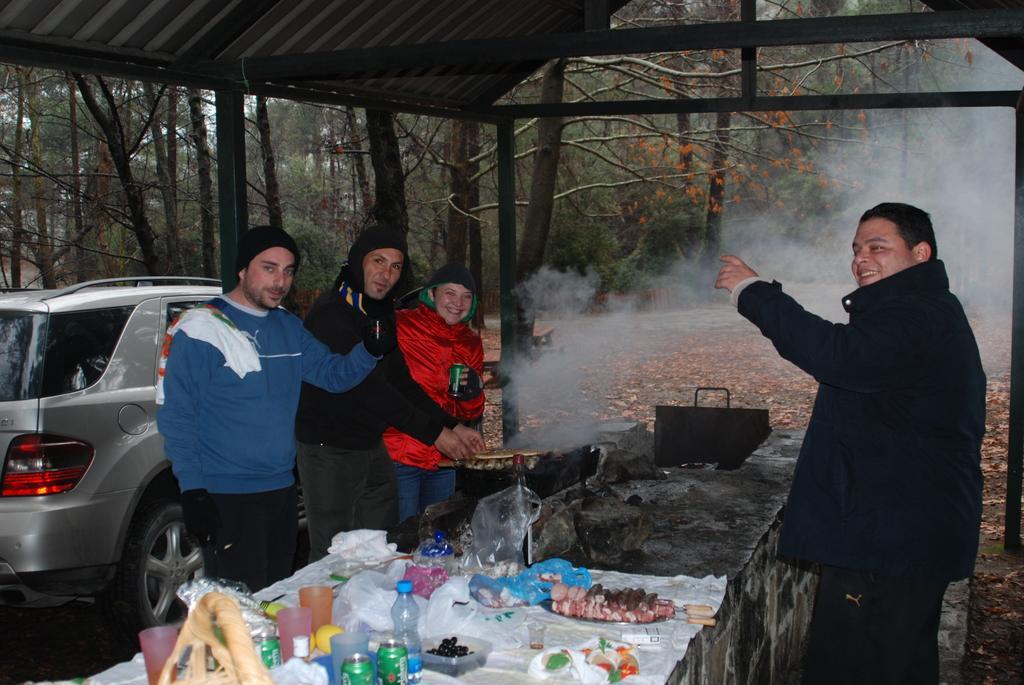How would you summarize this image in a sentence or two? In this image, we can see people and are wearing coats and some are wearing scarves and caps and we can see a grille, smoke and some food items, bottles, tins, glasses and some other items on the stone. In the background, there are trees and we can see a car. At the top, there is a roof. 